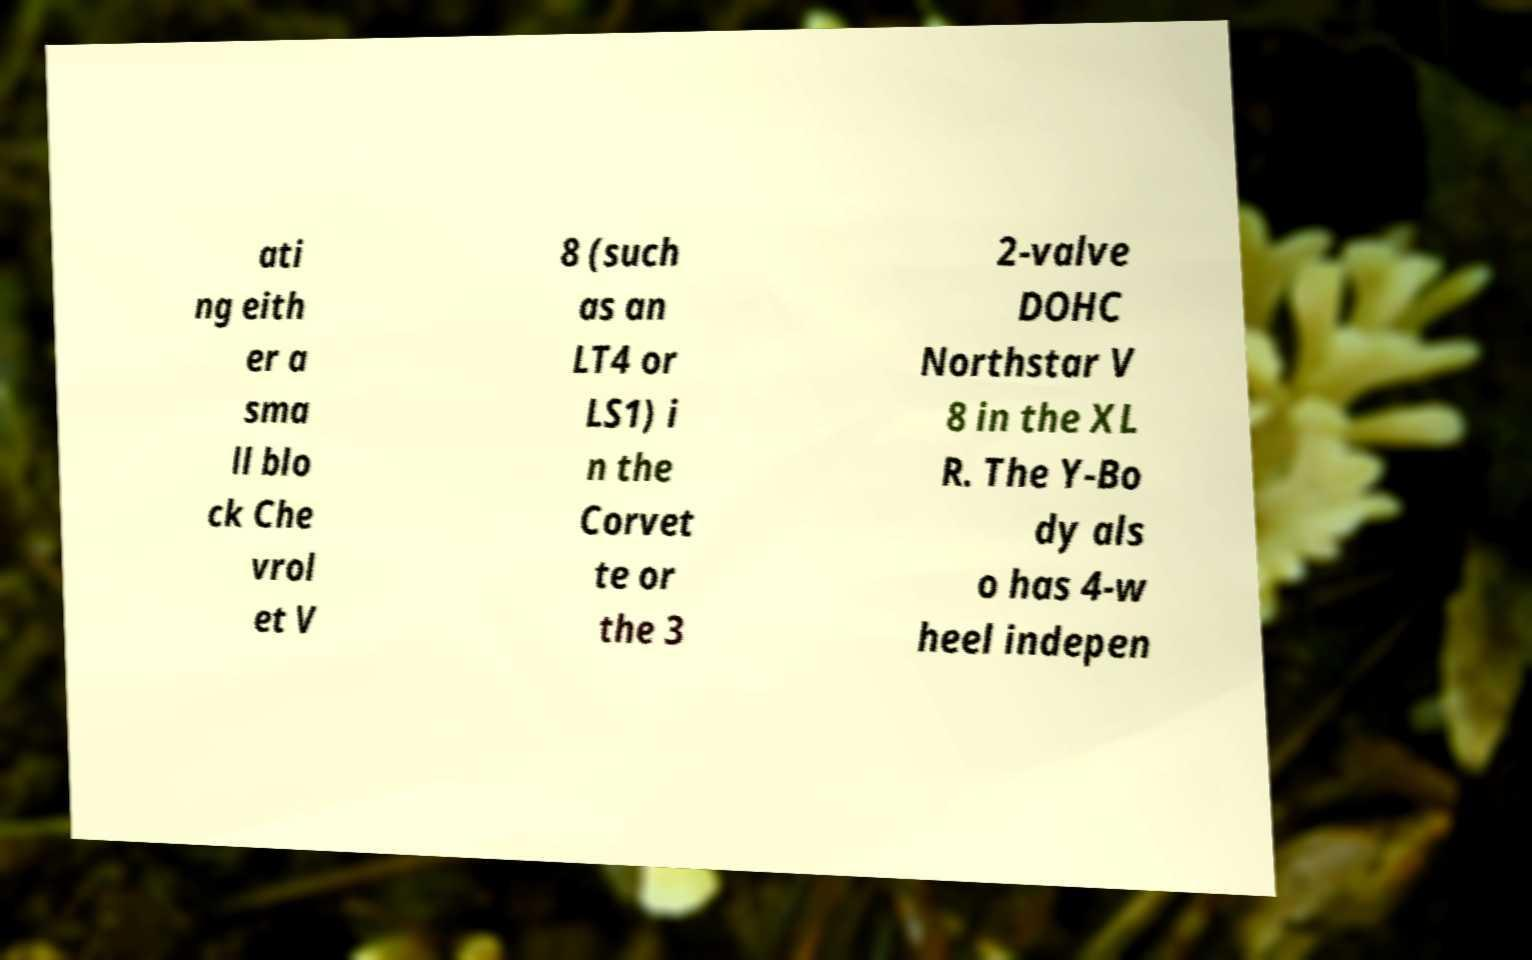I need the written content from this picture converted into text. Can you do that? ati ng eith er a sma ll blo ck Che vrol et V 8 (such as an LT4 or LS1) i n the Corvet te or the 3 2-valve DOHC Northstar V 8 in the XL R. The Y-Bo dy als o has 4-w heel indepen 